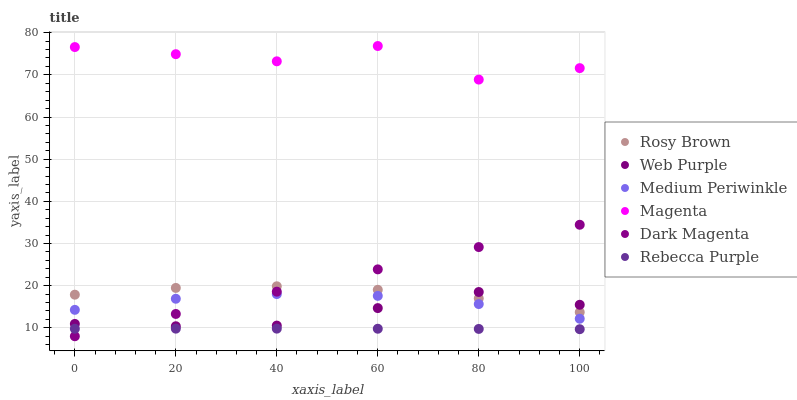Does Rebecca Purple have the minimum area under the curve?
Answer yes or no. Yes. Does Magenta have the maximum area under the curve?
Answer yes or no. Yes. Does Rosy Brown have the minimum area under the curve?
Answer yes or no. No. Does Rosy Brown have the maximum area under the curve?
Answer yes or no. No. Is Dark Magenta the smoothest?
Answer yes or no. Yes. Is Magenta the roughest?
Answer yes or no. Yes. Is Rosy Brown the smoothest?
Answer yes or no. No. Is Rosy Brown the roughest?
Answer yes or no. No. Does Dark Magenta have the lowest value?
Answer yes or no. Yes. Does Rosy Brown have the lowest value?
Answer yes or no. No. Does Magenta have the highest value?
Answer yes or no. Yes. Does Rosy Brown have the highest value?
Answer yes or no. No. Is Rebecca Purple less than Medium Periwinkle?
Answer yes or no. Yes. Is Medium Periwinkle greater than Rebecca Purple?
Answer yes or no. Yes. Does Dark Magenta intersect Rosy Brown?
Answer yes or no. Yes. Is Dark Magenta less than Rosy Brown?
Answer yes or no. No. Is Dark Magenta greater than Rosy Brown?
Answer yes or no. No. Does Rebecca Purple intersect Medium Periwinkle?
Answer yes or no. No. 